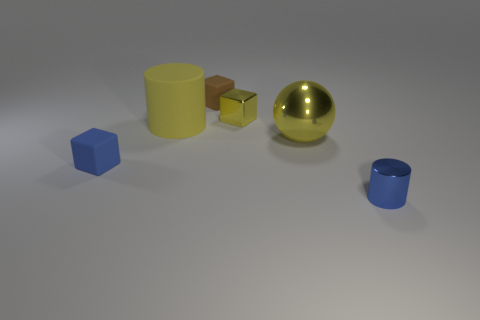Subtract all brown cubes. How many cubes are left? 2 Add 4 big cylinders. How many objects exist? 10 Subtract all brown cubes. How many cubes are left? 2 Subtract 1 cylinders. How many cylinders are left? 1 Subtract all tiny gray metallic cubes. Subtract all small matte things. How many objects are left? 4 Add 5 large cylinders. How many large cylinders are left? 6 Add 3 blue metallic things. How many blue metallic things exist? 4 Subtract 1 yellow spheres. How many objects are left? 5 Subtract all spheres. How many objects are left? 5 Subtract all blue cylinders. Subtract all gray balls. How many cylinders are left? 1 